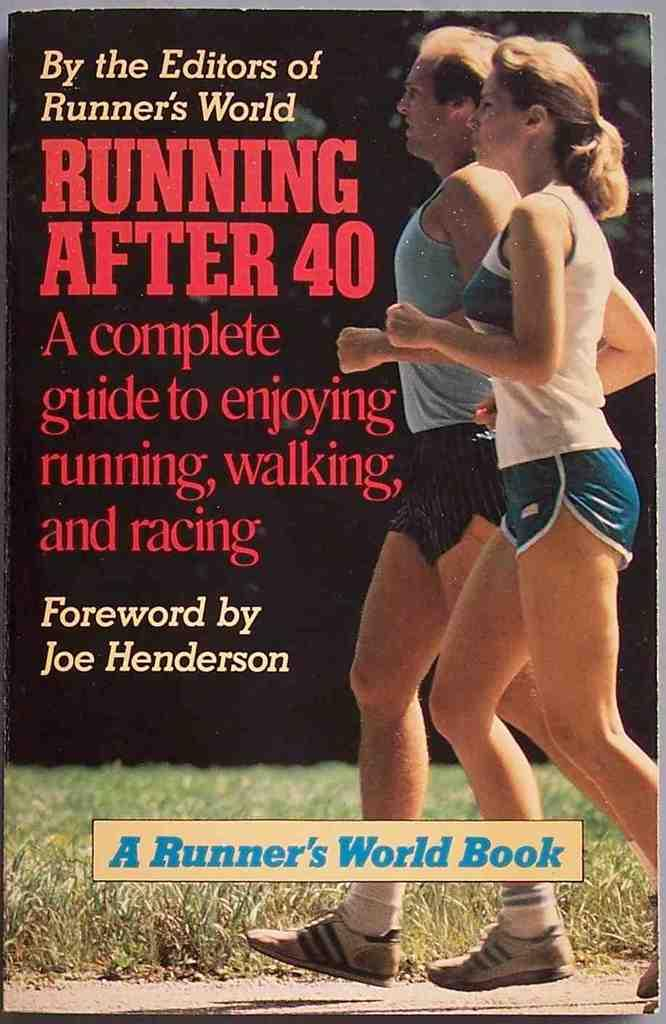<image>
Provide a brief description of the given image. Runner's world editors have tips on running after 40. 